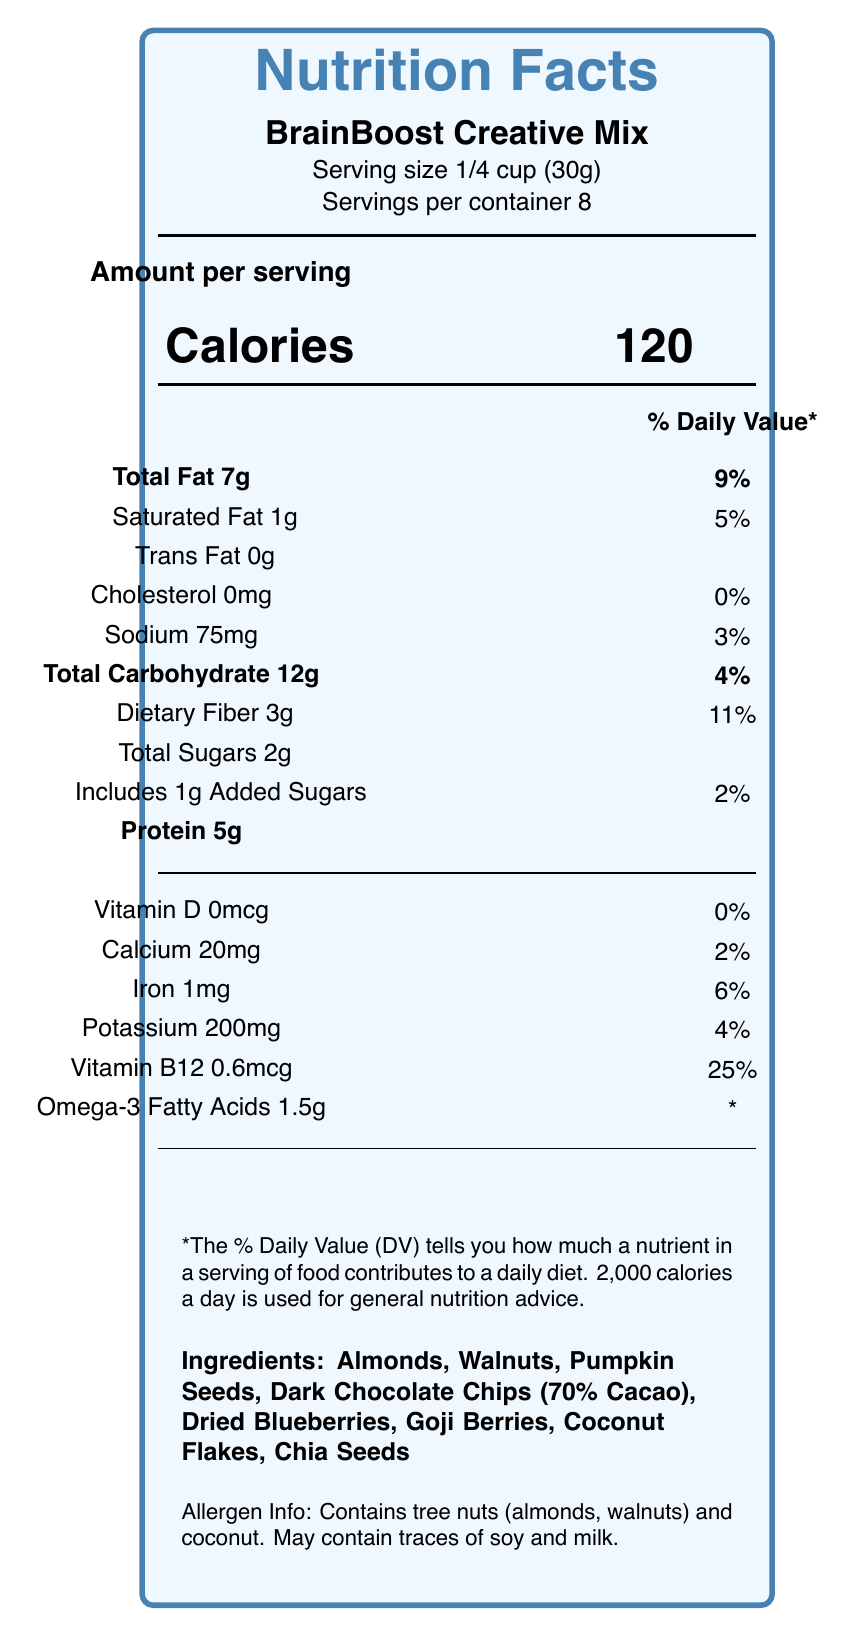What is the serving size of the BrainBoost Creative Mix? The serving size is directly stated on the label as "Serving size 1/4 cup (30g)".
Answer: 1/4 cup (30g) How many calories are there in one serving? The label lists "Calories 120" for one serving.
Answer: 120 What is the approximate daily value percentage of dietary fiber in one serving? The label states "Dietary Fiber 3g ; 11%".
Answer: 11% What are the two main allergens mentioned in the allergen information? The allergen information section specifically mentions "tree nuts (almonds, walnuts) and coconut".
Answer: Tree nuts (almonds, walnuts) and coconut How much vitamin B12 does one serving contain? The label indicates that Vitamin B12 content is "0.6mcg".
Answer: 0.6mcg Which type of nuts are included in the ingredients? A. Peanuts and cashews B. Almonds and walnuts C. Pistachios and hazelnuts The ingredients list almonds and walnuts among the components.
Answer: B. Almonds and walnuts What percentage of the daily value of calcium does one serving provide? A. 0% B. 2% C. 6% D. 25% The label states that the product provides 2% of the daily value for calcium.
Answer: B. 2% Is the product an excellent source of omega-3 fatty acids? In the health claims, it is noted that the product is an "Excellent source of omega-3 fatty acids".
Answer: Yes Describe the main idea of the document. The document provides essential nutritional information such as calories, fat, carbohydrates, protein content, vitamins, minerals, and specific health claims. It describes the product as a blend designed to support cognitive function and sustained energy through ingredients like nuts, berries, and dark chocolate.
Answer: The document is a Nutrition Facts Label for BrainBoost Creative Mix, a low-calorie, brain-boosting snack mix created by a nutritionist for creative professionals. It details serving size, nutritional content, ingredients, allergen information, health benefits, and other relevant information. What is the total amount of sugars, including added sugars, in one serving? The label specifies "Total Sugars 2g" and "Includes 1g Added Sugars".
Answer: 2g total sugars, including 1g added sugars Can you find the lot number on the label? The lot number "BBA2023051" is listed on the label.
Answer: Yes Does the product provide any vitamin D? The label states "Vitamin D 0mcg" with a daily value of "0%".
Answer: No What amount of protein does one serving contain? The label indicates the protein content as "Protein 5g".
Answer: 5g What is the expiration date of the product? The label mentions "best by date 09/30/2024".
Answer: 09/30/2024 Who developed this BrainBoost Creative Mix? The product description mentions that it was developed by nutritionist Dr. Elena Summers.
Answer: Dr. Elena Summers, a nutritionist. What is the bar code number for the product? The bar code displayed on the label is "890123456789".
Answer: 890123456789 What inspired J.K. Thornton to endorse BrainBoost Creative Mix? The author endorsement by J.K. Thornton explains that the mix helps maintain focus and creativity during long writing sessions.
Answer: The importance of maintaining focus and creativity during long writing sessions. How many servings are in each container? The label specifies "Servings per container 8".
Answer: 8 Can you determine the price of the BrainBoost Creative Mix from this label? The label does not provide any information related to the price of the product.
Answer: Cannot be determined What is the company that manufactures the BrainBoost Creative Mix? The label lists "NutriGenius Labs, Inc." as the manufacturer.
Answer: NutriGenius Labs, Inc. What is the role of dark chocolate chips in the health benefits of BrainBoost Creative Mix? A. Source of protein B. Contains antioxidants C. Reduces sodium D. Adds Vitamin D The health claims mention that dark chocolate contains antioxidants.
Answer: B. Contains antioxidants 